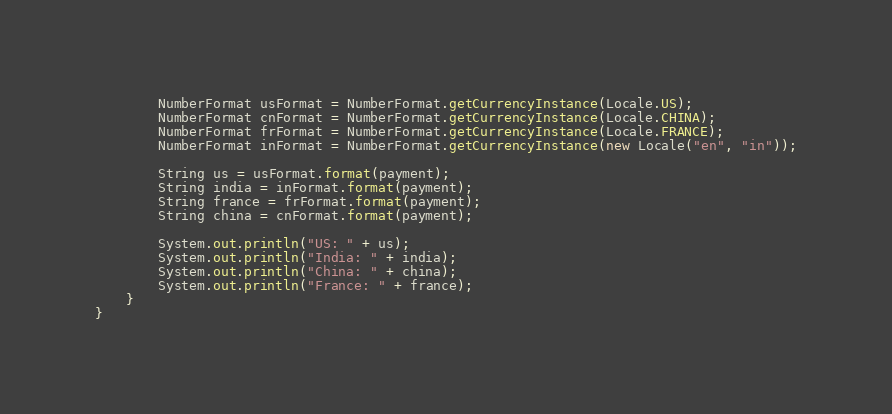Convert code to text. <code><loc_0><loc_0><loc_500><loc_500><_Java_>		NumberFormat usFormat = NumberFormat.getCurrencyInstance(Locale.US);
		NumberFormat cnFormat = NumberFormat.getCurrencyInstance(Locale.CHINA);
		NumberFormat frFormat = NumberFormat.getCurrencyInstance(Locale.FRANCE);
		NumberFormat inFormat = NumberFormat.getCurrencyInstance(new Locale("en", "in"));

		String us = usFormat.format(payment);
		String india = inFormat.format(payment);
		String france = frFormat.format(payment);
		String china = cnFormat.format(payment);

		System.out.println("US: " + us);
		System.out.println("India: " + india);
		System.out.println("China: " + china);
		System.out.println("France: " + france);
	}
}
</code> 